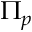<formula> <loc_0><loc_0><loc_500><loc_500>\Pi _ { p }</formula> 